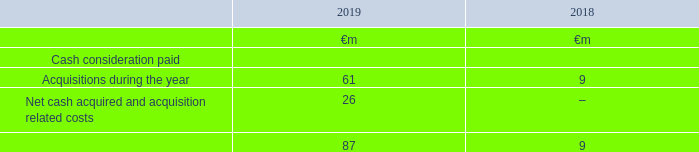26. Acquisitions and disposals
We completed a number of acquisitions and disposals during the year. The note below provides details of these transactions as well as those in the prior year. For further details see “Critical accounting judgements and key sources of estimation uncertainty” in note 1 “Basis of preparation” to the consolidated financial statements.
Accounting policies
Business combinations
Acquisitions of subsidiaries are accounted for using the acquisition method. The cost of the acquisition is measured at the aggregate of the fair values at the date of exchange of assets given, liabilities incurred or assumed and equity instruments issued by the Group. Acquisition-related costs are recognised in the income statement as incurred. The acquiree’s identifiable assets and liabilities are recognised at their fair values at the acquisition date. Goodwill is measured as the excess of the sum of the consideration transferred, the amount of any non-controlling interests in the acquiree and the fair value of the Group’s previously held equity interest in the acquiree, if any, over the net amounts of identifiable assets acquired and liabilities assumed at the acquisition date. The interest of the non-controlling shareholders in the acquiree may initially be measured either at fair value or at the non-controlling shareholders’ proportion of the net fair value of the identifiable assets acquired, liabilities and contingent liabilities assumed. The choice of measurement basis is made on an acquisition-by-acquisition basis. Acquisitions of subsidiaries are accounted for using the acquisition method. The cost of the acquisition is measured at the aggregate of the fair values at the date of exchange of assets given, liabilities incurred or assumed and equity instruments issued by the Group. Acquisition-related costs are recognised in the income statement as incurred. The acquiree’s identifiable assets and liabilities are recognised at their fair values at the acquisition date. Goodwill is measured as the excess of the sum of the consideration transferred, the amount of any non-controlling interests in the acquiree and the fair value of the Group’s previously held equity interest in the acquiree, if any, over the net amounts of identifiable assets acquired and liabilities assumed at the acquisition date. The interest of the non-controlling shareholders in the acquiree may initially be measured either at fair value or at the non-controlling shareholders’ proportion of the net fair value of the identifiable assets acquired, liabilities and contingent liabilities assumed. The choice of measurement basis is made on an acquisition-by-acquisition basis.
Acquisition of interests from non-controlling shareholders
In transactions with non-controlling parties that do not result in a change in control, the difference between the fair value of the consideration paid or received and the amount by which the non-controlling interest is adjusted is recognised in equity
The aggregate cash consideration in respect of purchases in subsidiaries, net of cash acquired, is as follows:
During the year ended 31 March 2019 the Group completed certain acquisitions for an aggregate net cash consideration of €87 million. The aggregate fair values of goodwill, identifiable assets, and liabilities of the acquired operations were €77 million, €123 million and €139 million respectively.
What does cash consideration paid comprise of? Acquisitions during the year, net cash acquired and acquisition related costs. Which financial years' information is shown in the table? 2018, 2019. How much is the 2019 acquisitions during the year ?
Answer scale should be: million. 61. Between 2018 and 2019, which year had a greater amount of acquisitions during the year? 61>9
Answer: 2019. Between 2018 and 2019, which year had a greater amount of cash consideration paid? 87>9
Answer: 2019. What percentage of 2019 average cash consideration paid is the 2019 average acquisitions during the year?
Answer scale should be: percent. [(61+9)/2] / [(87+9)/2]
Answer: 72.92. 